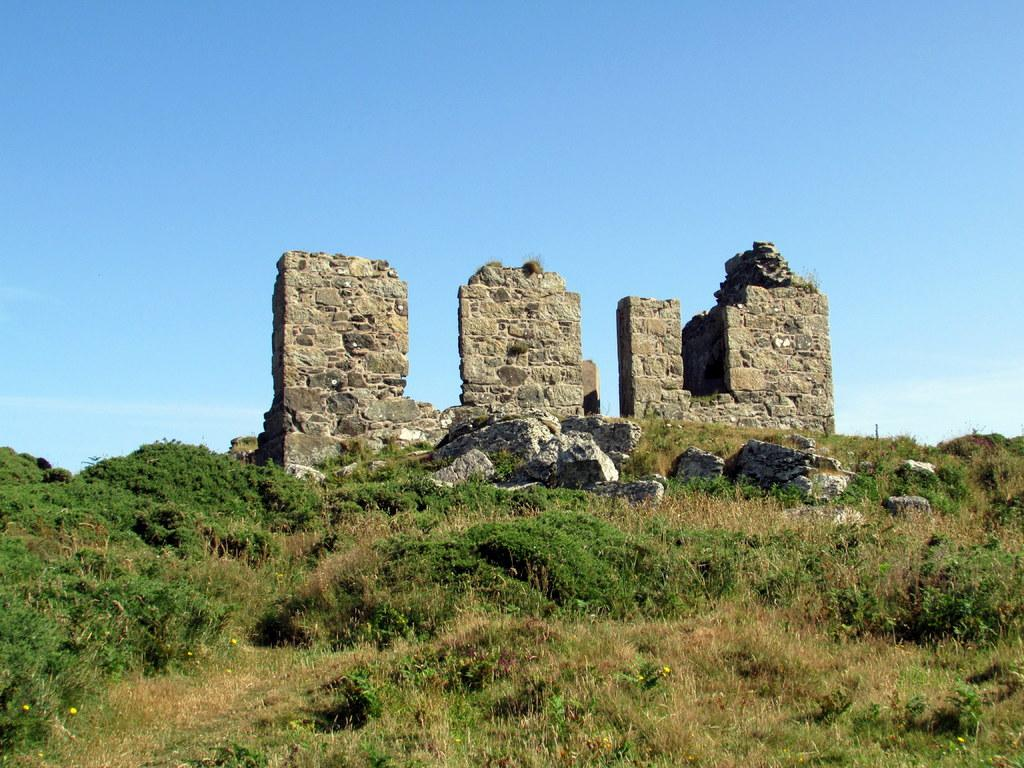What type of vegetation is present on the ground in the front of the image? There is grass on the ground in the front of the image. What can be seen in the center of the image? There are plants in the center of the image. What is located in the background of the image? There is a wall in the background of the image. What color is the paint on the wall in the downtown area of the image? There is no mention of paint or a downtown area in the image, so we cannot answer this question. 